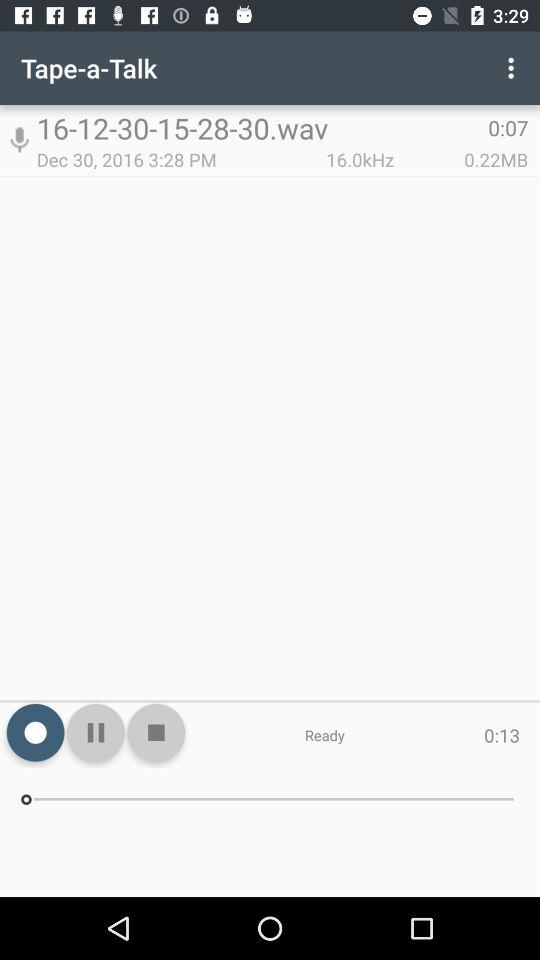What is the time duration of the audio "16-12-30-15-28-30.wav"? The duration of the audio is 0:07. 